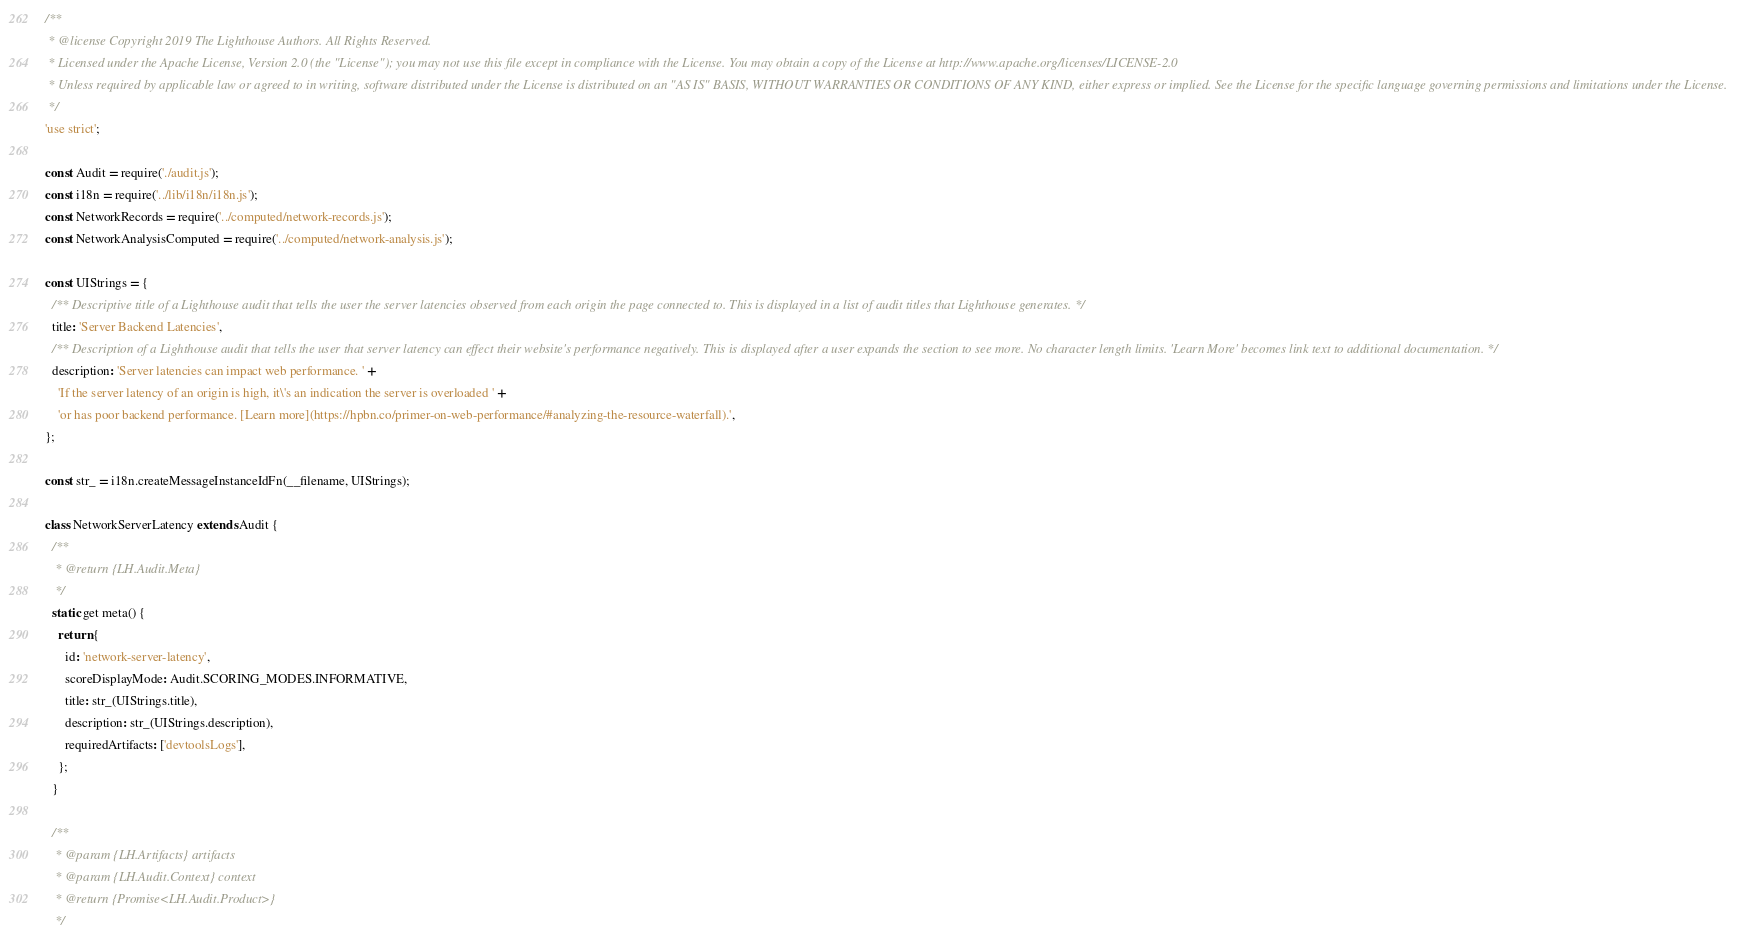<code> <loc_0><loc_0><loc_500><loc_500><_JavaScript_>/**
 * @license Copyright 2019 The Lighthouse Authors. All Rights Reserved.
 * Licensed under the Apache License, Version 2.0 (the "License"); you may not use this file except in compliance with the License. You may obtain a copy of the License at http://www.apache.org/licenses/LICENSE-2.0
 * Unless required by applicable law or agreed to in writing, software distributed under the License is distributed on an "AS IS" BASIS, WITHOUT WARRANTIES OR CONDITIONS OF ANY KIND, either express or implied. See the License for the specific language governing permissions and limitations under the License.
 */
'use strict';

const Audit = require('./audit.js');
const i18n = require('../lib/i18n/i18n.js');
const NetworkRecords = require('../computed/network-records.js');
const NetworkAnalysisComputed = require('../computed/network-analysis.js');

const UIStrings = {
  /** Descriptive title of a Lighthouse audit that tells the user the server latencies observed from each origin the page connected to. This is displayed in a list of audit titles that Lighthouse generates. */
  title: 'Server Backend Latencies',
  /** Description of a Lighthouse audit that tells the user that server latency can effect their website's performance negatively. This is displayed after a user expands the section to see more. No character length limits. 'Learn More' becomes link text to additional documentation. */
  description: 'Server latencies can impact web performance. ' +
    'If the server latency of an origin is high, it\'s an indication the server is overloaded ' +
    'or has poor backend performance. [Learn more](https://hpbn.co/primer-on-web-performance/#analyzing-the-resource-waterfall).',
};

const str_ = i18n.createMessageInstanceIdFn(__filename, UIStrings);

class NetworkServerLatency extends Audit {
  /**
   * @return {LH.Audit.Meta}
   */
  static get meta() {
    return {
      id: 'network-server-latency',
      scoreDisplayMode: Audit.SCORING_MODES.INFORMATIVE,
      title: str_(UIStrings.title),
      description: str_(UIStrings.description),
      requiredArtifacts: ['devtoolsLogs'],
    };
  }

  /**
   * @param {LH.Artifacts} artifacts
   * @param {LH.Audit.Context} context
   * @return {Promise<LH.Audit.Product>}
   */</code> 